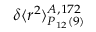Convert formula to latex. <formula><loc_0><loc_0><loc_500><loc_500>\delta \langle r ^ { 2 } \rangle _ { P _ { 1 2 } ( 9 ) } ^ { A , 1 7 2 }</formula> 